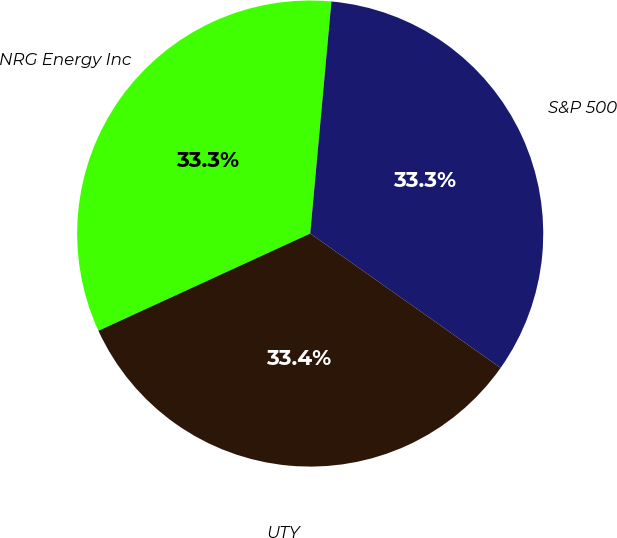<chart> <loc_0><loc_0><loc_500><loc_500><pie_chart><fcel>NRG Energy Inc<fcel>S&P 500<fcel>UTY<nl><fcel>33.3%<fcel>33.33%<fcel>33.37%<nl></chart> 